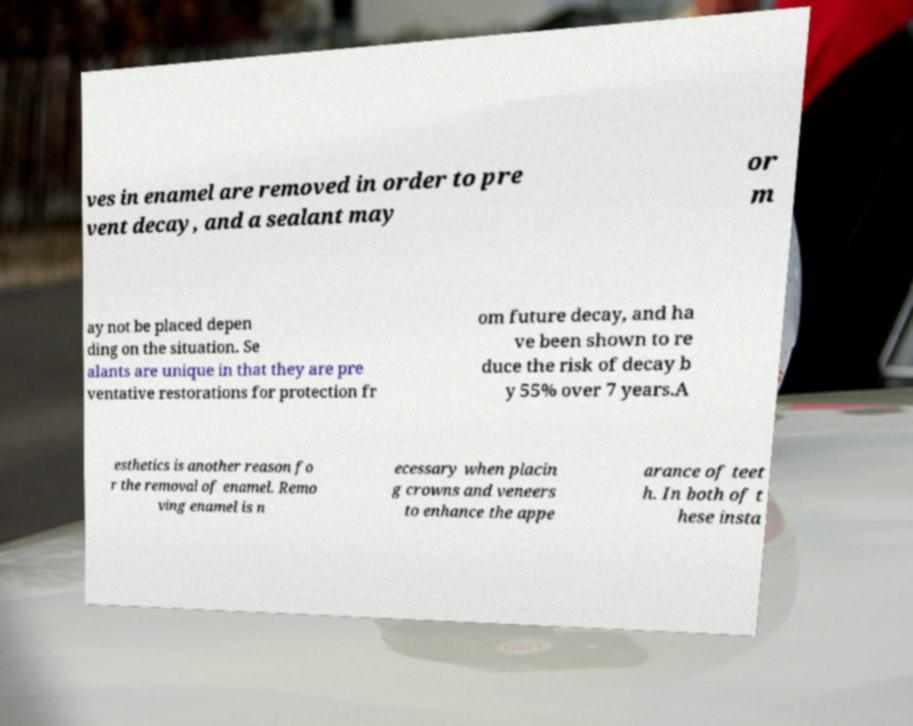Can you accurately transcribe the text from the provided image for me? ves in enamel are removed in order to pre vent decay, and a sealant may or m ay not be placed depen ding on the situation. Se alants are unique in that they are pre ventative restorations for protection fr om future decay, and ha ve been shown to re duce the risk of decay b y 55% over 7 years.A esthetics is another reason fo r the removal of enamel. Remo ving enamel is n ecessary when placin g crowns and veneers to enhance the appe arance of teet h. In both of t hese insta 